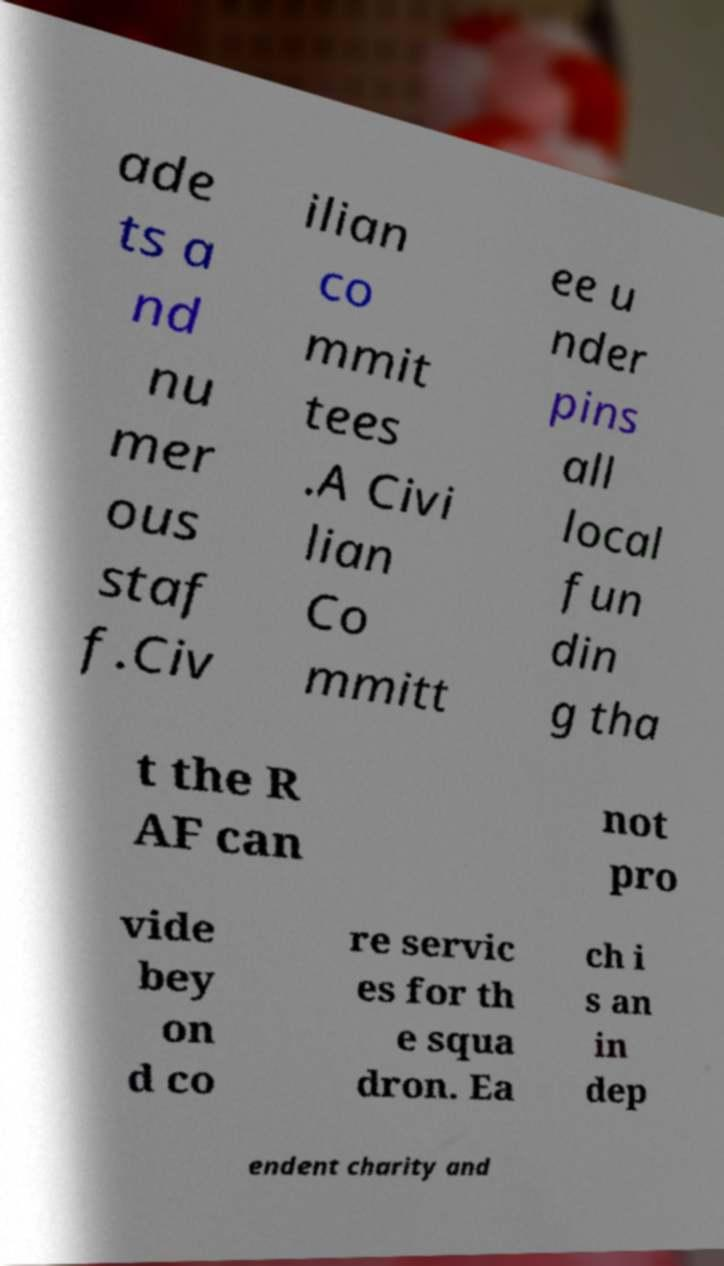There's text embedded in this image that I need extracted. Can you transcribe it verbatim? ade ts a nd nu mer ous staf f.Civ ilian co mmit tees .A Civi lian Co mmitt ee u nder pins all local fun din g tha t the R AF can not pro vide bey on d co re servic es for th e squa dron. Ea ch i s an in dep endent charity and 